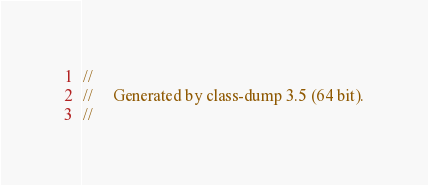Convert code to text. <code><loc_0><loc_0><loc_500><loc_500><_C_>//
//     Generated by class-dump 3.5 (64 bit).
//</code> 